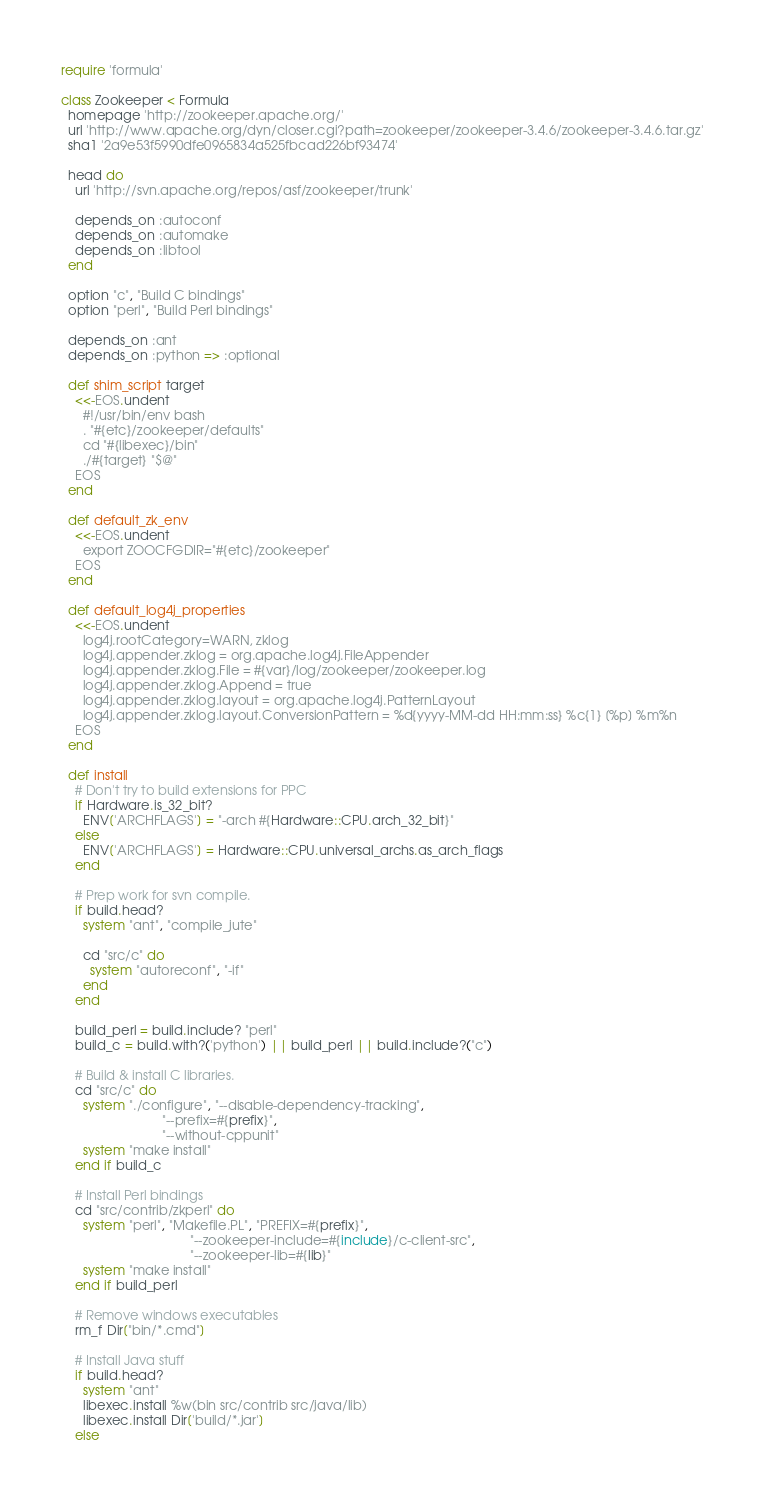<code> <loc_0><loc_0><loc_500><loc_500><_Ruby_>require 'formula'

class Zookeeper < Formula
  homepage 'http://zookeeper.apache.org/'
  url 'http://www.apache.org/dyn/closer.cgi?path=zookeeper/zookeeper-3.4.6/zookeeper-3.4.6.tar.gz'
  sha1 '2a9e53f5990dfe0965834a525fbcad226bf93474'

  head do
    url 'http://svn.apache.org/repos/asf/zookeeper/trunk'

    depends_on :autoconf
    depends_on :automake
    depends_on :libtool
  end

  option "c", "Build C bindings"
  option "perl", "Build Perl bindings"

  depends_on :ant
  depends_on :python => :optional

  def shim_script target
    <<-EOS.undent
      #!/usr/bin/env bash
      . "#{etc}/zookeeper/defaults"
      cd "#{libexec}/bin"
      ./#{target} "$@"
    EOS
  end

  def default_zk_env
    <<-EOS.undent
      export ZOOCFGDIR="#{etc}/zookeeper"
    EOS
  end

  def default_log4j_properties
    <<-EOS.undent
      log4j.rootCategory=WARN, zklog
      log4j.appender.zklog = org.apache.log4j.FileAppender
      log4j.appender.zklog.File = #{var}/log/zookeeper/zookeeper.log
      log4j.appender.zklog.Append = true
      log4j.appender.zklog.layout = org.apache.log4j.PatternLayout
      log4j.appender.zklog.layout.ConversionPattern = %d{yyyy-MM-dd HH:mm:ss} %c{1} [%p] %m%n
    EOS
  end

  def install
    # Don't try to build extensions for PPC
    if Hardware.is_32_bit?
      ENV['ARCHFLAGS'] = "-arch #{Hardware::CPU.arch_32_bit}"
    else
      ENV['ARCHFLAGS'] = Hardware::CPU.universal_archs.as_arch_flags
    end

    # Prep work for svn compile.
    if build.head?
      system "ant", "compile_jute"

      cd "src/c" do
        system "autoreconf", "-if"
      end
    end

    build_perl = build.include? "perl"
    build_c = build.with?('python') || build_perl || build.include?("c")

    # Build & install C libraries.
    cd "src/c" do
      system "./configure", "--disable-dependency-tracking",
                            "--prefix=#{prefix}",
                            "--without-cppunit"
      system "make install"
    end if build_c

    # Install Perl bindings
    cd "src/contrib/zkperl" do
      system "perl", "Makefile.PL", "PREFIX=#{prefix}",
                                    "--zookeeper-include=#{include}/c-client-src",
                                    "--zookeeper-lib=#{lib}"
      system "make install"
    end if build_perl

    # Remove windows executables
    rm_f Dir["bin/*.cmd"]

    # Install Java stuff
    if build.head?
      system "ant"
      libexec.install %w(bin src/contrib src/java/lib)
      libexec.install Dir['build/*.jar']
    else</code> 